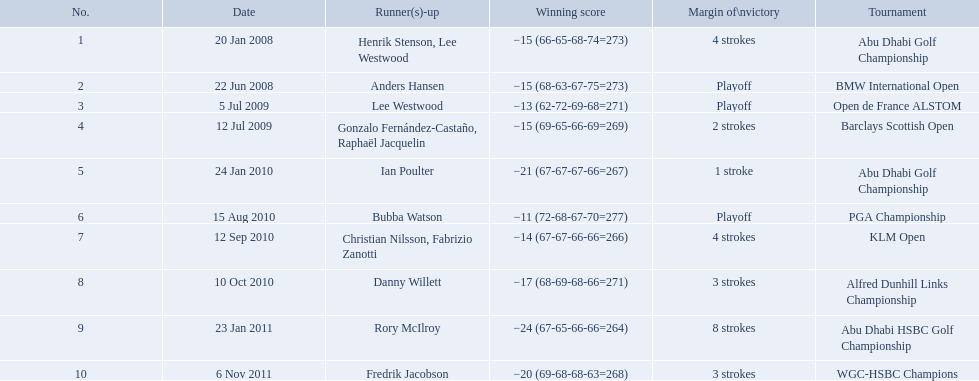What were all of the tournaments martin played in? Abu Dhabi Golf Championship, BMW International Open, Open de France ALSTOM, Barclays Scottish Open, Abu Dhabi Golf Championship, PGA Championship, KLM Open, Alfred Dunhill Links Championship, Abu Dhabi HSBC Golf Championship, WGC-HSBC Champions. And how many strokes did he score? −15 (66-65-68-74=273), −15 (68-63-67-75=273), −13 (62-72-69-68=271), −15 (69-65-66-69=269), −21 (67-67-67-66=267), −11 (72-68-67-70=277), −14 (67-67-66-66=266), −17 (68-69-68-66=271), −24 (67-65-66-66=264), −20 (69-68-68-63=268). What about during barclays and klm? −15 (69-65-66-69=269), −14 (67-67-66-66=266). How many more were scored in klm? 2 strokes. How many strokes were in the klm open by martin kaymer? 4 strokes. How many strokes were in the abu dhabi golf championship? 4 strokes. How many more strokes were there in the klm than the barclays open? 2 strokes. 